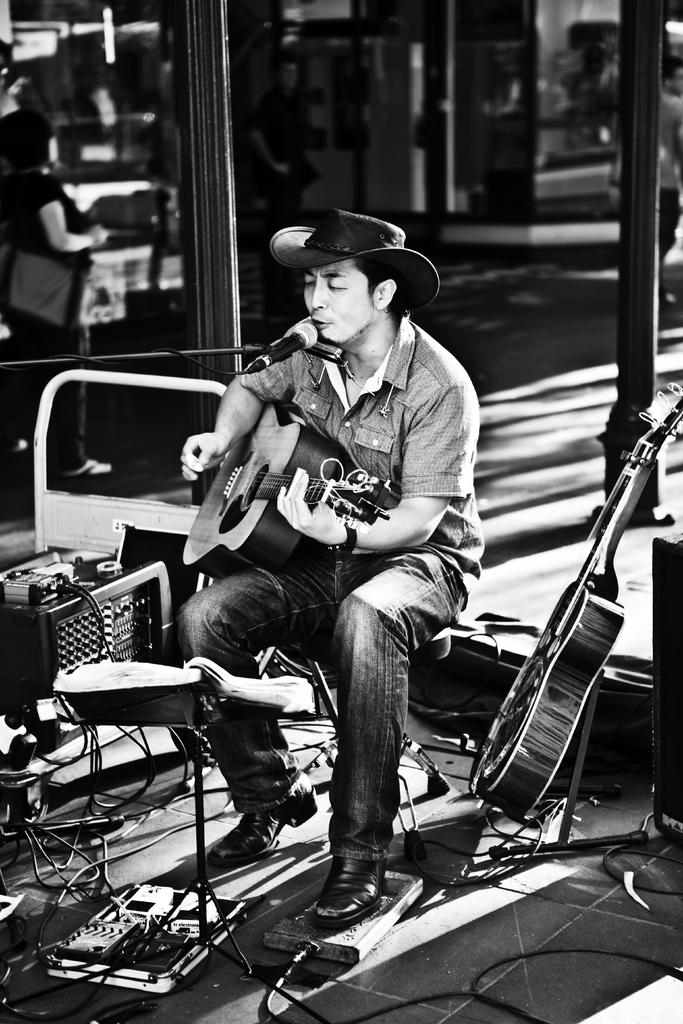What is the main subject of the image? The main subject of the image is a man. What is the man doing in the image? The man is sitting on a chair, holding a guitar, and singing into a microphone. What is the man wearing on his head? The man is wearing a cap. What other objects are visible in the image? There are multiple musical instruments visible behind the man. What type of grain is being used to make the loaf of bread in the image? There is no loaf of bread present in the image; it features a man playing a guitar and singing into a microphone. What type of approval is the man seeking from the audience in the image? The image does not depict the man seeking approval from the audience; he is simply playing his guitar and singing. 